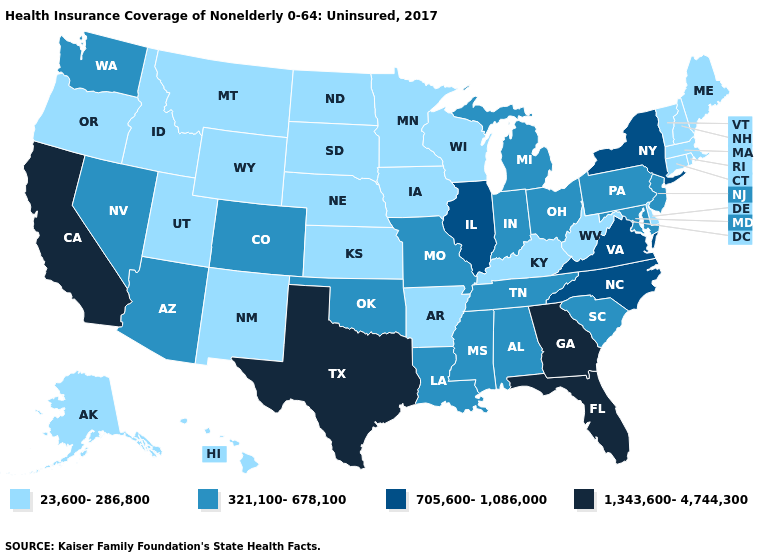Does Michigan have the same value as Iowa?
Quick response, please. No. Does the first symbol in the legend represent the smallest category?
Be succinct. Yes. What is the highest value in the MidWest ?
Be succinct. 705,600-1,086,000. Which states have the lowest value in the USA?
Concise answer only. Alaska, Arkansas, Connecticut, Delaware, Hawaii, Idaho, Iowa, Kansas, Kentucky, Maine, Massachusetts, Minnesota, Montana, Nebraska, New Hampshire, New Mexico, North Dakota, Oregon, Rhode Island, South Dakota, Utah, Vermont, West Virginia, Wisconsin, Wyoming. Which states have the lowest value in the Northeast?
Short answer required. Connecticut, Maine, Massachusetts, New Hampshire, Rhode Island, Vermont. Name the states that have a value in the range 1,343,600-4,744,300?
Quick response, please. California, Florida, Georgia, Texas. What is the value of Delaware?
Answer briefly. 23,600-286,800. Does Alabama have a lower value than Massachusetts?
Give a very brief answer. No. What is the value of Missouri?
Answer briefly. 321,100-678,100. Which states have the highest value in the USA?
Answer briefly. California, Florida, Georgia, Texas. What is the highest value in the USA?
Answer briefly. 1,343,600-4,744,300. What is the value of Wisconsin?
Concise answer only. 23,600-286,800. What is the lowest value in states that border Texas?
Write a very short answer. 23,600-286,800. What is the lowest value in the Northeast?
Answer briefly. 23,600-286,800. Does the first symbol in the legend represent the smallest category?
Be succinct. Yes. 